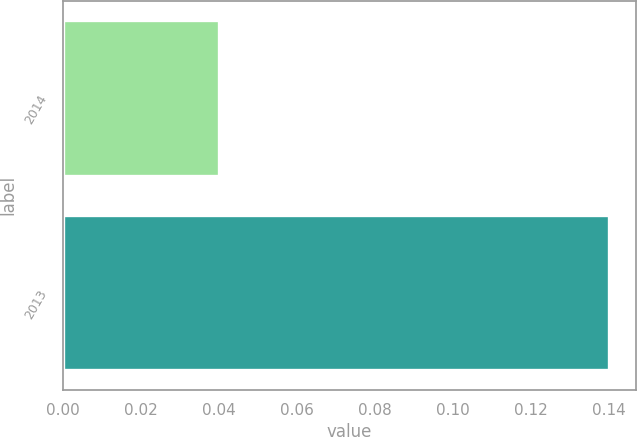Convert chart. <chart><loc_0><loc_0><loc_500><loc_500><bar_chart><fcel>2014<fcel>2013<nl><fcel>0.04<fcel>0.14<nl></chart> 